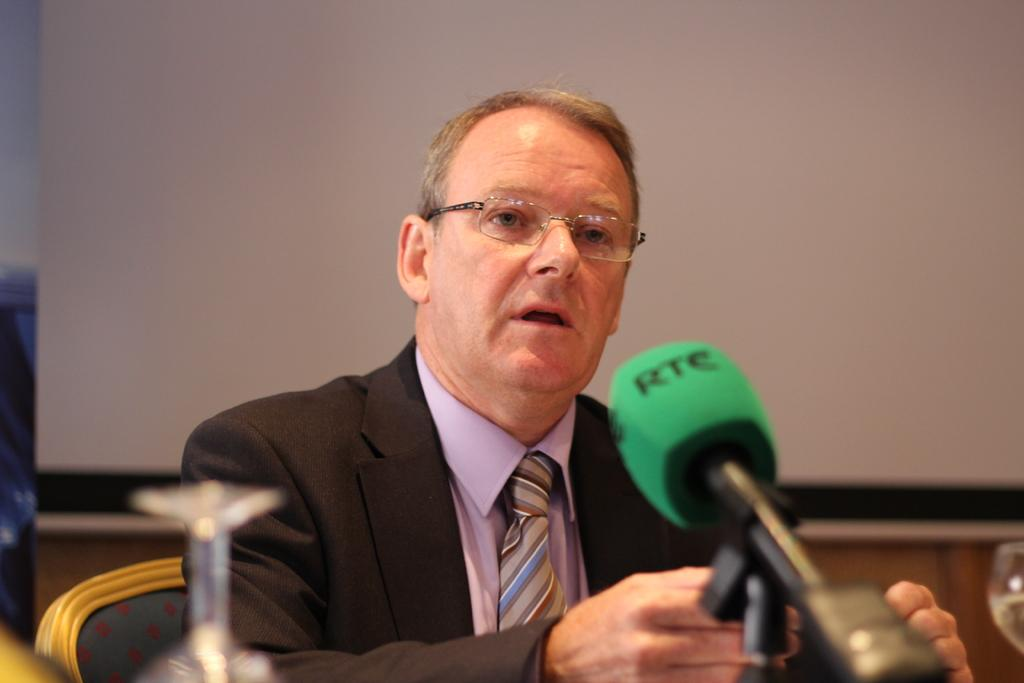What is the main subject of the image? There is a person in the image. What is the person doing in the image? The person is sitting and talking. What object is present in front of the person? There is a microphone in front of the person. Where is the sign with the crown located in the image? There is no sign or crown present in the image. 